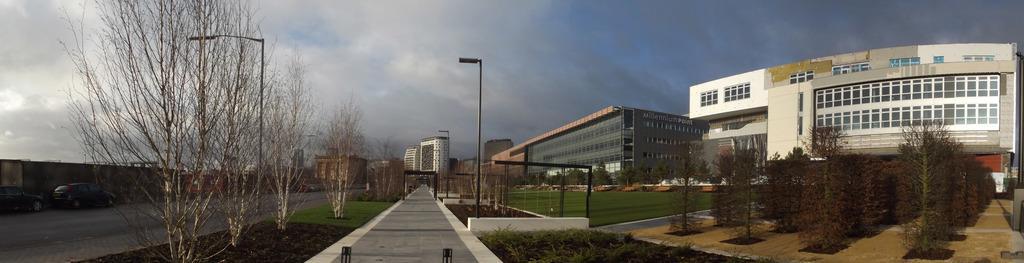How would you summarize this image in a sentence or two? This image is taken outdoors. At the top of the image there is a sky with clouds. At the bottom of the image there are two roads and a garden with grass, trees and plants. On the right side of the image there are a few buildings. On the left side of the image a few cars are parked on the road. In the middle of the image there are a few buildings and poles with street lights. 